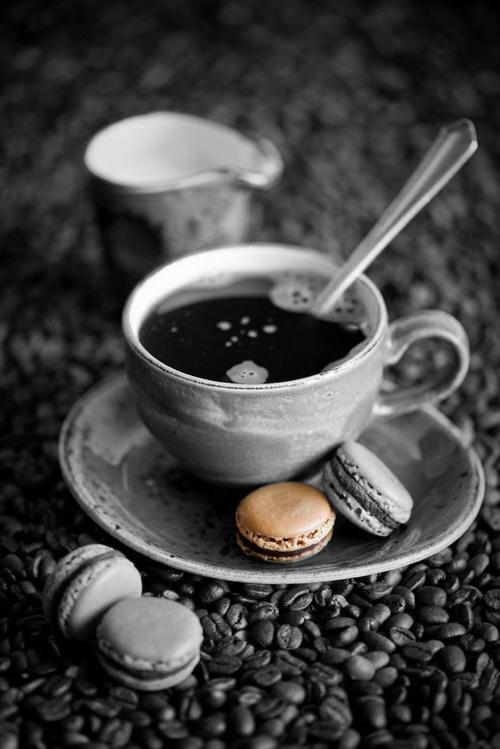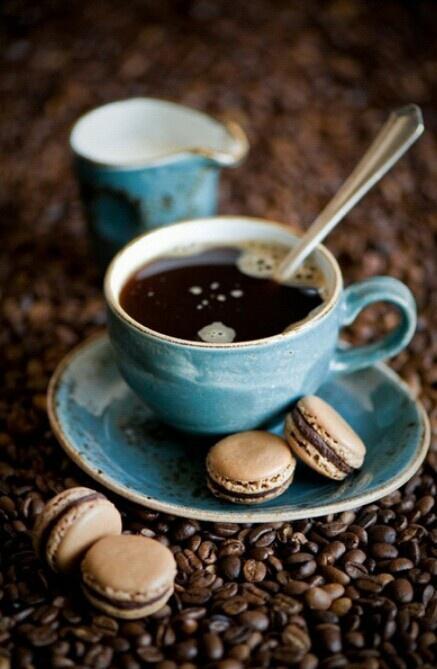The first image is the image on the left, the second image is the image on the right. Analyze the images presented: Is the assertion "There are at least four cups of coffee." valid? Answer yes or no. No. The first image is the image on the left, the second image is the image on the right. Analyze the images presented: Is the assertion "An image shows two cups of beverage, with spoons nearby." valid? Answer yes or no. No. 